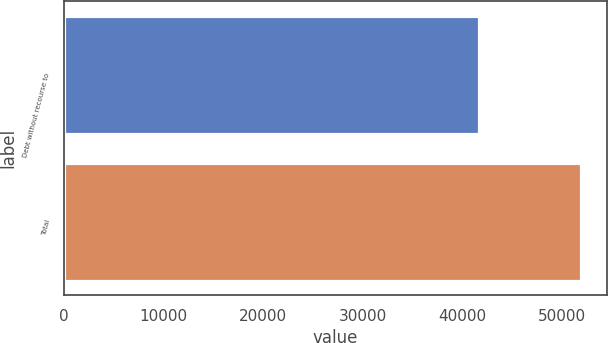Convert chart. <chart><loc_0><loc_0><loc_500><loc_500><bar_chart><fcel>Debt without recourse to<fcel>Total<nl><fcel>41655<fcel>51931<nl></chart> 